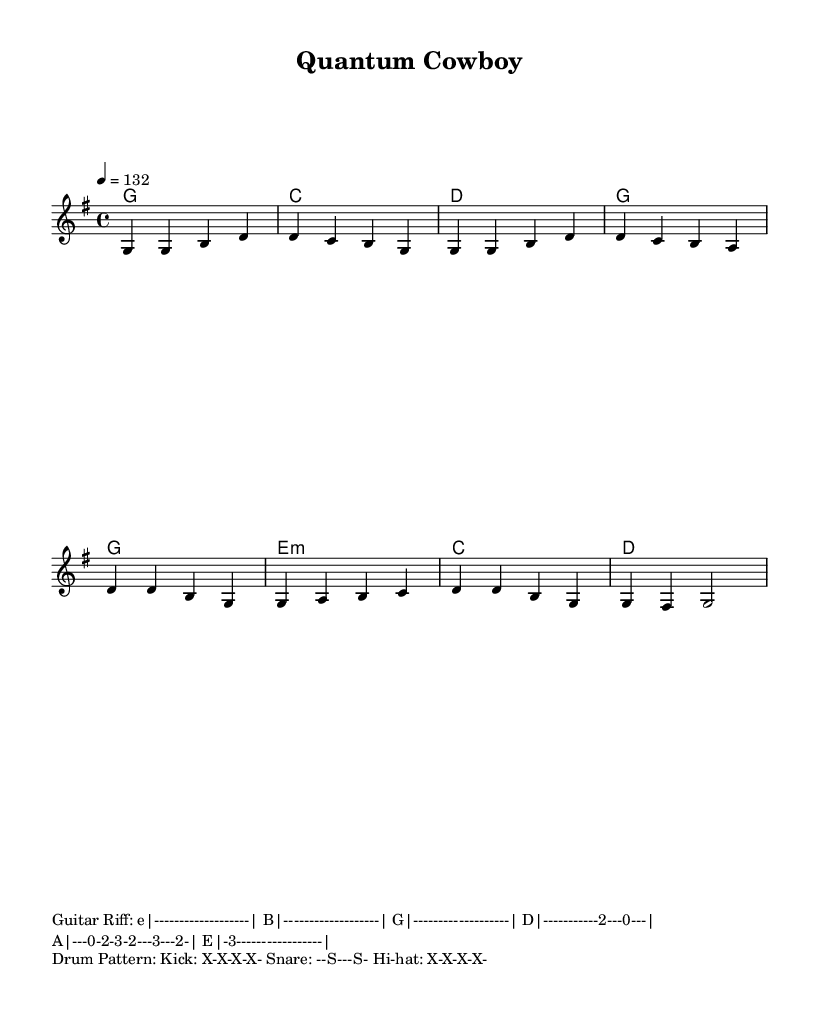What is the key signature of this music? The key signature is G major, which has one sharp (F#). This can be identified in the “\key g \major” line of the code, denoting the tonality.
Answer: G major What is the time signature of this piece? The time signature is 4/4, which indicates four beats per measure. This is found in the “\time 4/4” line of the code, specifying the rhythm of the music.
Answer: 4/4 What is the tempo marking for this track? The tempo marking is indicated as 132 beats per minute, which can be found in the “\tempo 4 = 132” line of the code. This sets the pace of the piece.
Answer: 132 What musical style is represented in this piece? The musical style is characterized as "Country Rock," indicated by the overall content and energy of the track, specifically in the title and the genre characteristics in the lyrics that combine country themes with rock elements.
Answer: Country Rock What is the defining thematic lyric of the chorus? The defining thematic lyric of the chorus is "I'm a quantum cowboy," which encapsulates the primary metaphor linking country imagery with quantum mechanics. This phrase is part of the chorus lyrics provided.
Answer: I'm a quantum cowboy What type of guitar riff accompanies this music? The guitar riff provided is a chord progression that uses both standard plucking and power chords typical in Country Rock styles, evident from the presented guitar tab that illustrates the distinctive playing style for this genre.
Answer: Country Rock riff 